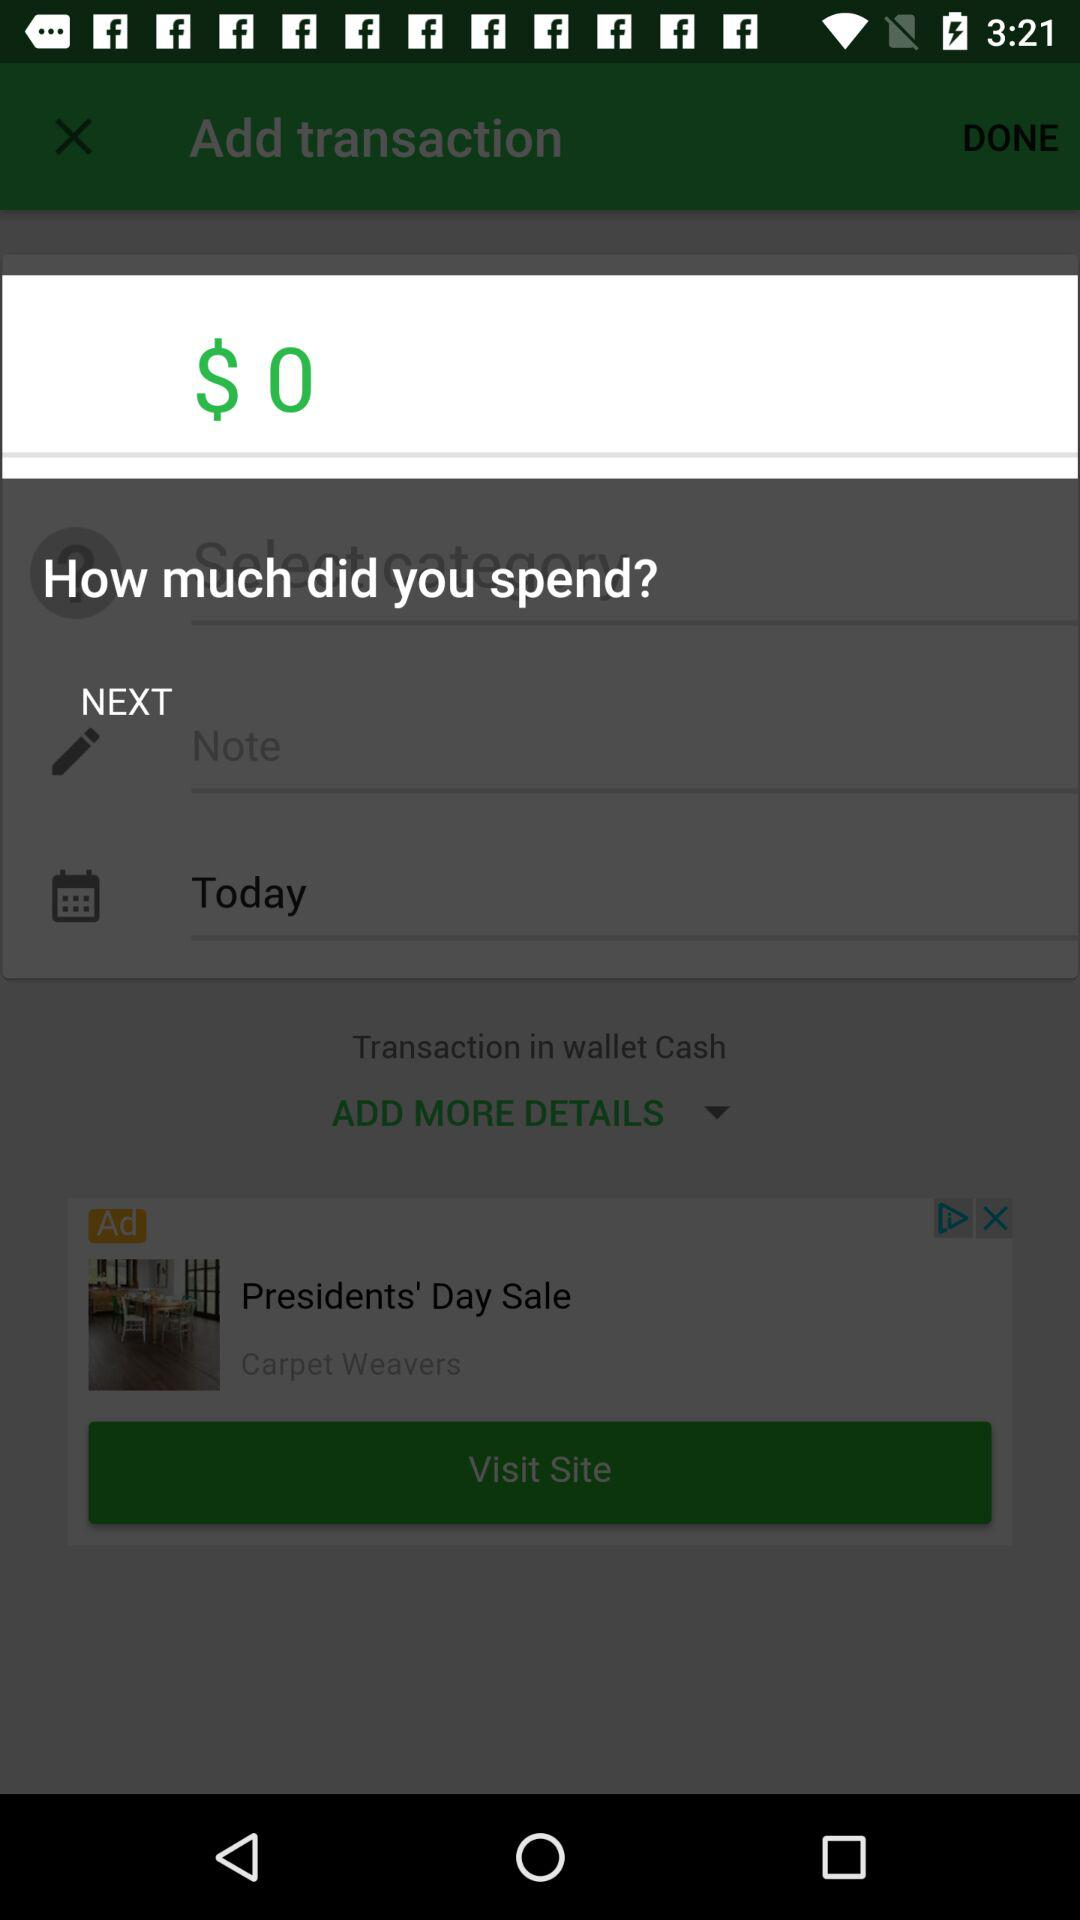How much has been spent?
When the provided information is insufficient, respond with <no answer>. <no answer> 